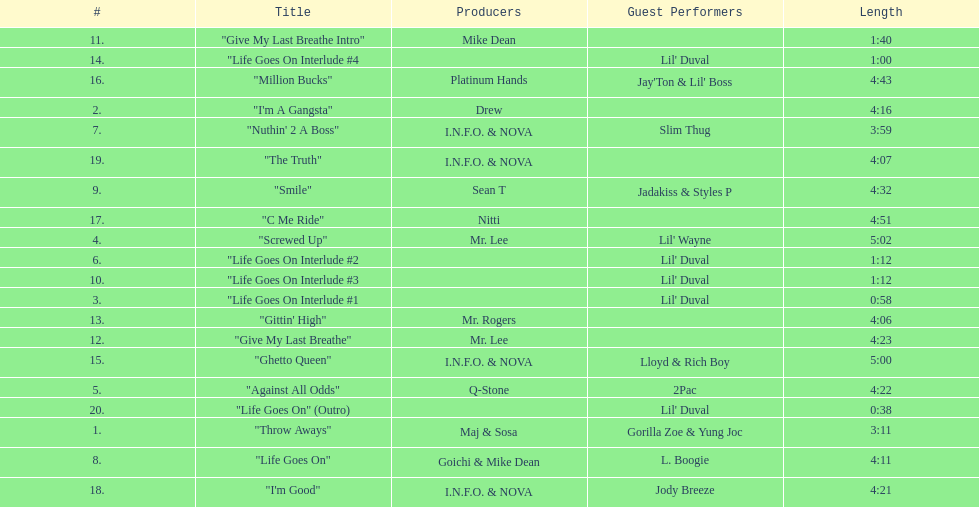What is the last track produced by mr. lee? "Give My Last Breathe". 